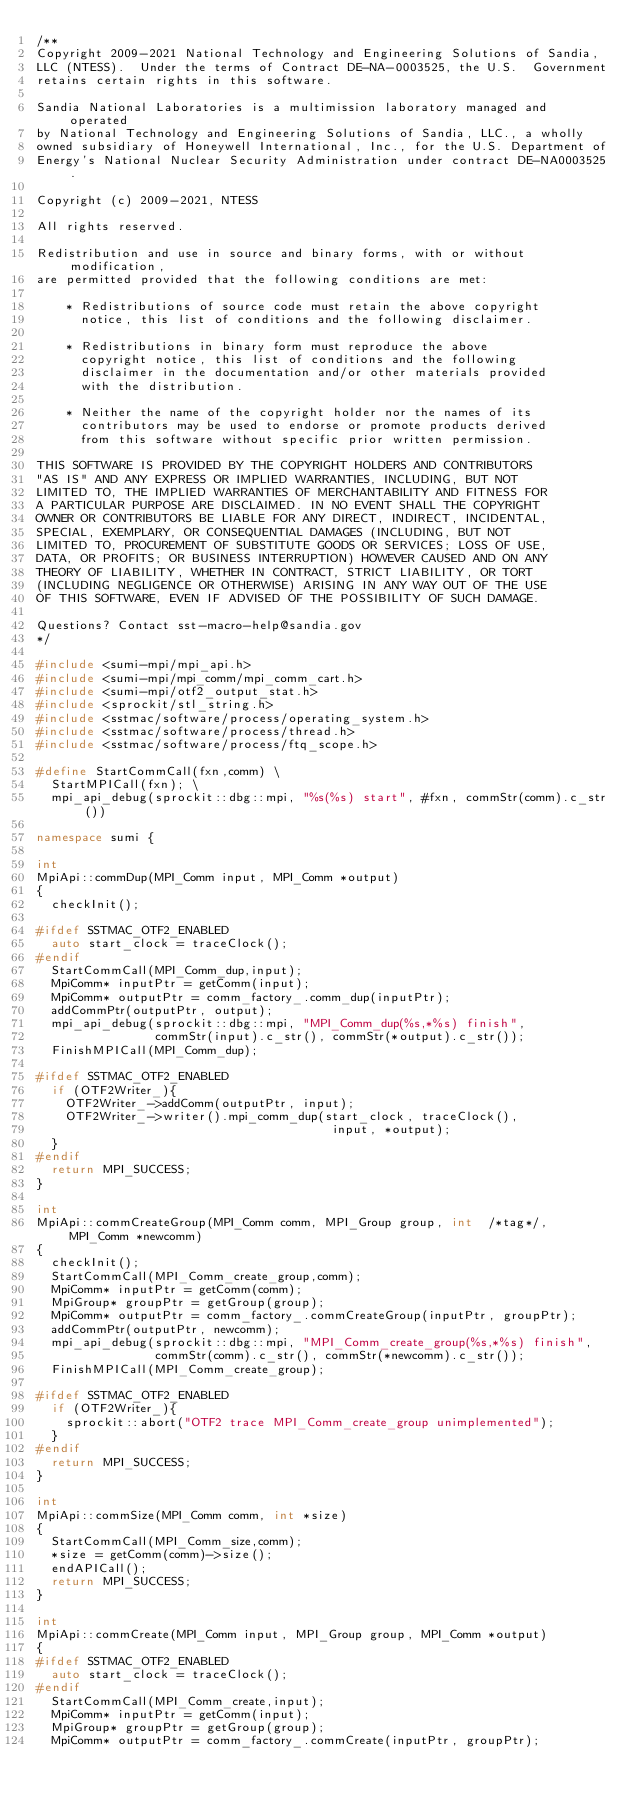Convert code to text. <code><loc_0><loc_0><loc_500><loc_500><_C++_>/**
Copyright 2009-2021 National Technology and Engineering Solutions of Sandia, 
LLC (NTESS).  Under the terms of Contract DE-NA-0003525, the U.S.  Government 
retains certain rights in this software.

Sandia National Laboratories is a multimission laboratory managed and operated
by National Technology and Engineering Solutions of Sandia, LLC., a wholly 
owned subsidiary of Honeywell International, Inc., for the U.S. Department of 
Energy's National Nuclear Security Administration under contract DE-NA0003525.

Copyright (c) 2009-2021, NTESS

All rights reserved.

Redistribution and use in source and binary forms, with or without modification, 
are permitted provided that the following conditions are met:

    * Redistributions of source code must retain the above copyright
      notice, this list of conditions and the following disclaimer.

    * Redistributions in binary form must reproduce the above
      copyright notice, this list of conditions and the following
      disclaimer in the documentation and/or other materials provided
      with the distribution.

    * Neither the name of the copyright holder nor the names of its
      contributors may be used to endorse or promote products derived
      from this software without specific prior written permission.

THIS SOFTWARE IS PROVIDED BY THE COPYRIGHT HOLDERS AND CONTRIBUTORS
"AS IS" AND ANY EXPRESS OR IMPLIED WARRANTIES, INCLUDING, BUT NOT
LIMITED TO, THE IMPLIED WARRANTIES OF MERCHANTABILITY AND FITNESS FOR
A PARTICULAR PURPOSE ARE DISCLAIMED. IN NO EVENT SHALL THE COPYRIGHT
OWNER OR CONTRIBUTORS BE LIABLE FOR ANY DIRECT, INDIRECT, INCIDENTAL,
SPECIAL, EXEMPLARY, OR CONSEQUENTIAL DAMAGES (INCLUDING, BUT NOT
LIMITED TO, PROCUREMENT OF SUBSTITUTE GOODS OR SERVICES; LOSS OF USE,
DATA, OR PROFITS; OR BUSINESS INTERRUPTION) HOWEVER CAUSED AND ON ANY
THEORY OF LIABILITY, WHETHER IN CONTRACT, STRICT LIABILITY, OR TORT
(INCLUDING NEGLIGENCE OR OTHERWISE) ARISING IN ANY WAY OUT OF THE USE
OF THIS SOFTWARE, EVEN IF ADVISED OF THE POSSIBILITY OF SUCH DAMAGE.

Questions? Contact sst-macro-help@sandia.gov
*/

#include <sumi-mpi/mpi_api.h>
#include <sumi-mpi/mpi_comm/mpi_comm_cart.h>
#include <sumi-mpi/otf2_output_stat.h>
#include <sprockit/stl_string.h>
#include <sstmac/software/process/operating_system.h>
#include <sstmac/software/process/thread.h>
#include <sstmac/software/process/ftq_scope.h>

#define StartCommCall(fxn,comm) \
  StartMPICall(fxn); \
  mpi_api_debug(sprockit::dbg::mpi, "%s(%s) start", #fxn, commStr(comm).c_str())

namespace sumi {

int
MpiApi::commDup(MPI_Comm input, MPI_Comm *output)
{
  checkInit();

#ifdef SSTMAC_OTF2_ENABLED
  auto start_clock = traceClock();
#endif
  StartCommCall(MPI_Comm_dup,input);
  MpiComm* inputPtr = getComm(input);
  MpiComm* outputPtr = comm_factory_.comm_dup(inputPtr);
  addCommPtr(outputPtr, output);
  mpi_api_debug(sprockit::dbg::mpi, "MPI_Comm_dup(%s,*%s) finish",
                commStr(input).c_str(), commStr(*output).c_str());
  FinishMPICall(MPI_Comm_dup);

#ifdef SSTMAC_OTF2_ENABLED
  if (OTF2Writer_){
    OTF2Writer_->addComm(outputPtr, input);
    OTF2Writer_->writer().mpi_comm_dup(start_clock, traceClock(),
                                        input, *output);
  }
#endif
  return MPI_SUCCESS;
}

int
MpiApi::commCreateGroup(MPI_Comm comm, MPI_Group group, int  /*tag*/, MPI_Comm *newcomm)
{
  checkInit();
  StartCommCall(MPI_Comm_create_group,comm);
  MpiComm* inputPtr = getComm(comm);
  MpiGroup* groupPtr = getGroup(group);
  MpiComm* outputPtr = comm_factory_.commCreateGroup(inputPtr, groupPtr);
  addCommPtr(outputPtr, newcomm);
  mpi_api_debug(sprockit::dbg::mpi, "MPI_Comm_create_group(%s,*%s) finish",
                commStr(comm).c_str(), commStr(*newcomm).c_str());
  FinishMPICall(MPI_Comm_create_group);

#ifdef SSTMAC_OTF2_ENABLED
  if (OTF2Writer_){
    sprockit::abort("OTF2 trace MPI_Comm_create_group unimplemented");
  }
#endif
  return MPI_SUCCESS;
}

int
MpiApi::commSize(MPI_Comm comm, int *size)
{
  StartCommCall(MPI_Comm_size,comm);
  *size = getComm(comm)->size();
  endAPICall();
  return MPI_SUCCESS;
}

int
MpiApi::commCreate(MPI_Comm input, MPI_Group group, MPI_Comm *output)
{
#ifdef SSTMAC_OTF2_ENABLED
  auto start_clock = traceClock();
#endif
  StartCommCall(MPI_Comm_create,input);
  MpiComm* inputPtr = getComm(input);
  MpiGroup* groupPtr = getGroup(group);
  MpiComm* outputPtr = comm_factory_.commCreate(inputPtr, groupPtr);</code> 